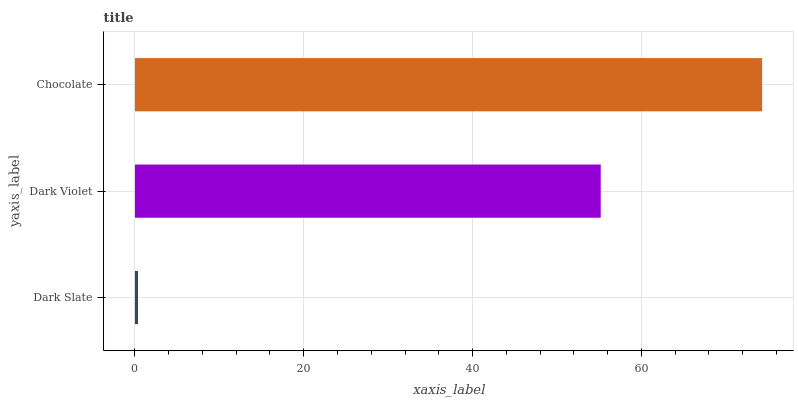Is Dark Slate the minimum?
Answer yes or no. Yes. Is Chocolate the maximum?
Answer yes or no. Yes. Is Dark Violet the minimum?
Answer yes or no. No. Is Dark Violet the maximum?
Answer yes or no. No. Is Dark Violet greater than Dark Slate?
Answer yes or no. Yes. Is Dark Slate less than Dark Violet?
Answer yes or no. Yes. Is Dark Slate greater than Dark Violet?
Answer yes or no. No. Is Dark Violet less than Dark Slate?
Answer yes or no. No. Is Dark Violet the high median?
Answer yes or no. Yes. Is Dark Violet the low median?
Answer yes or no. Yes. Is Dark Slate the high median?
Answer yes or no. No. Is Chocolate the low median?
Answer yes or no. No. 